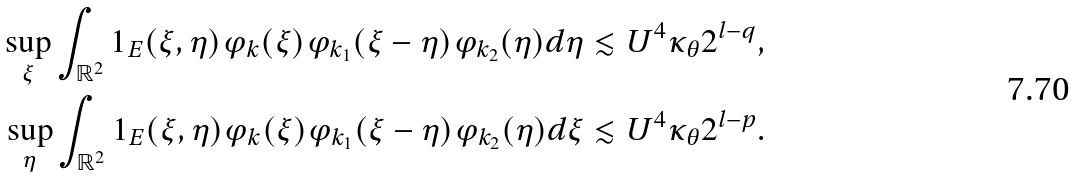Convert formula to latex. <formula><loc_0><loc_0><loc_500><loc_500>\sup _ { \xi } \int _ { \mathbb { R } ^ { 2 } } 1 _ { E } ( \xi , \eta ) \varphi _ { k } ( \xi ) \varphi _ { k _ { 1 } } ( \xi - \eta ) \varphi _ { k _ { 2 } } ( \eta ) d \eta & \lesssim U ^ { 4 } \kappa _ { \theta } 2 ^ { l - q } , \\ \sup _ { \eta } \int _ { \mathbb { R } ^ { 2 } } 1 _ { E } ( \xi , \eta ) \varphi _ { k } ( \xi ) \varphi _ { k _ { 1 } } ( \xi - \eta ) \varphi _ { k _ { 2 } } ( \eta ) d \xi & \lesssim U ^ { 4 } \kappa _ { \theta } 2 ^ { l - p } .</formula> 